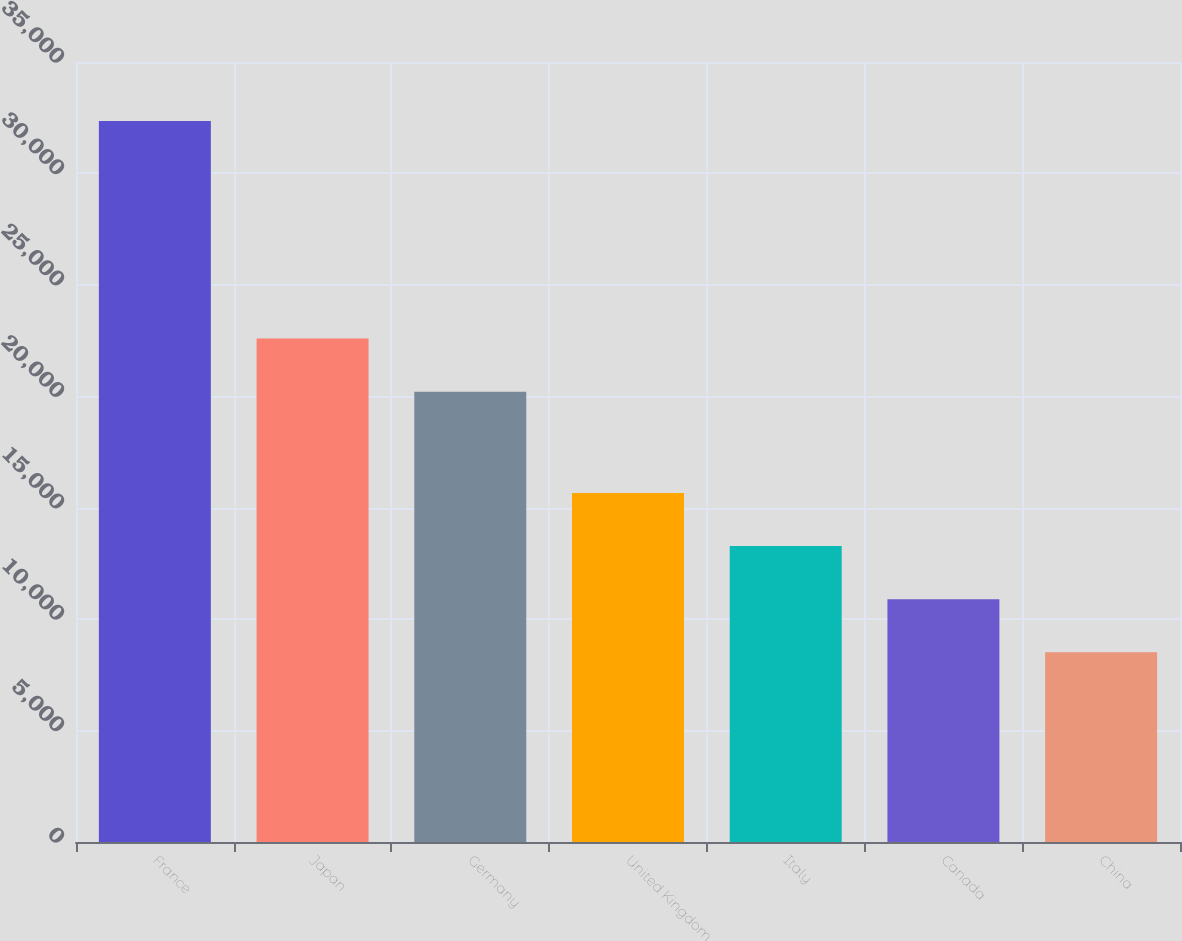Convert chart. <chart><loc_0><loc_0><loc_500><loc_500><bar_chart><fcel>France<fcel>Japan<fcel>Germany<fcel>United Kingdom<fcel>Italy<fcel>Canada<fcel>China<nl><fcel>32354<fcel>22589.2<fcel>20205<fcel>15664.6<fcel>13280.4<fcel>10896.2<fcel>8512<nl></chart> 